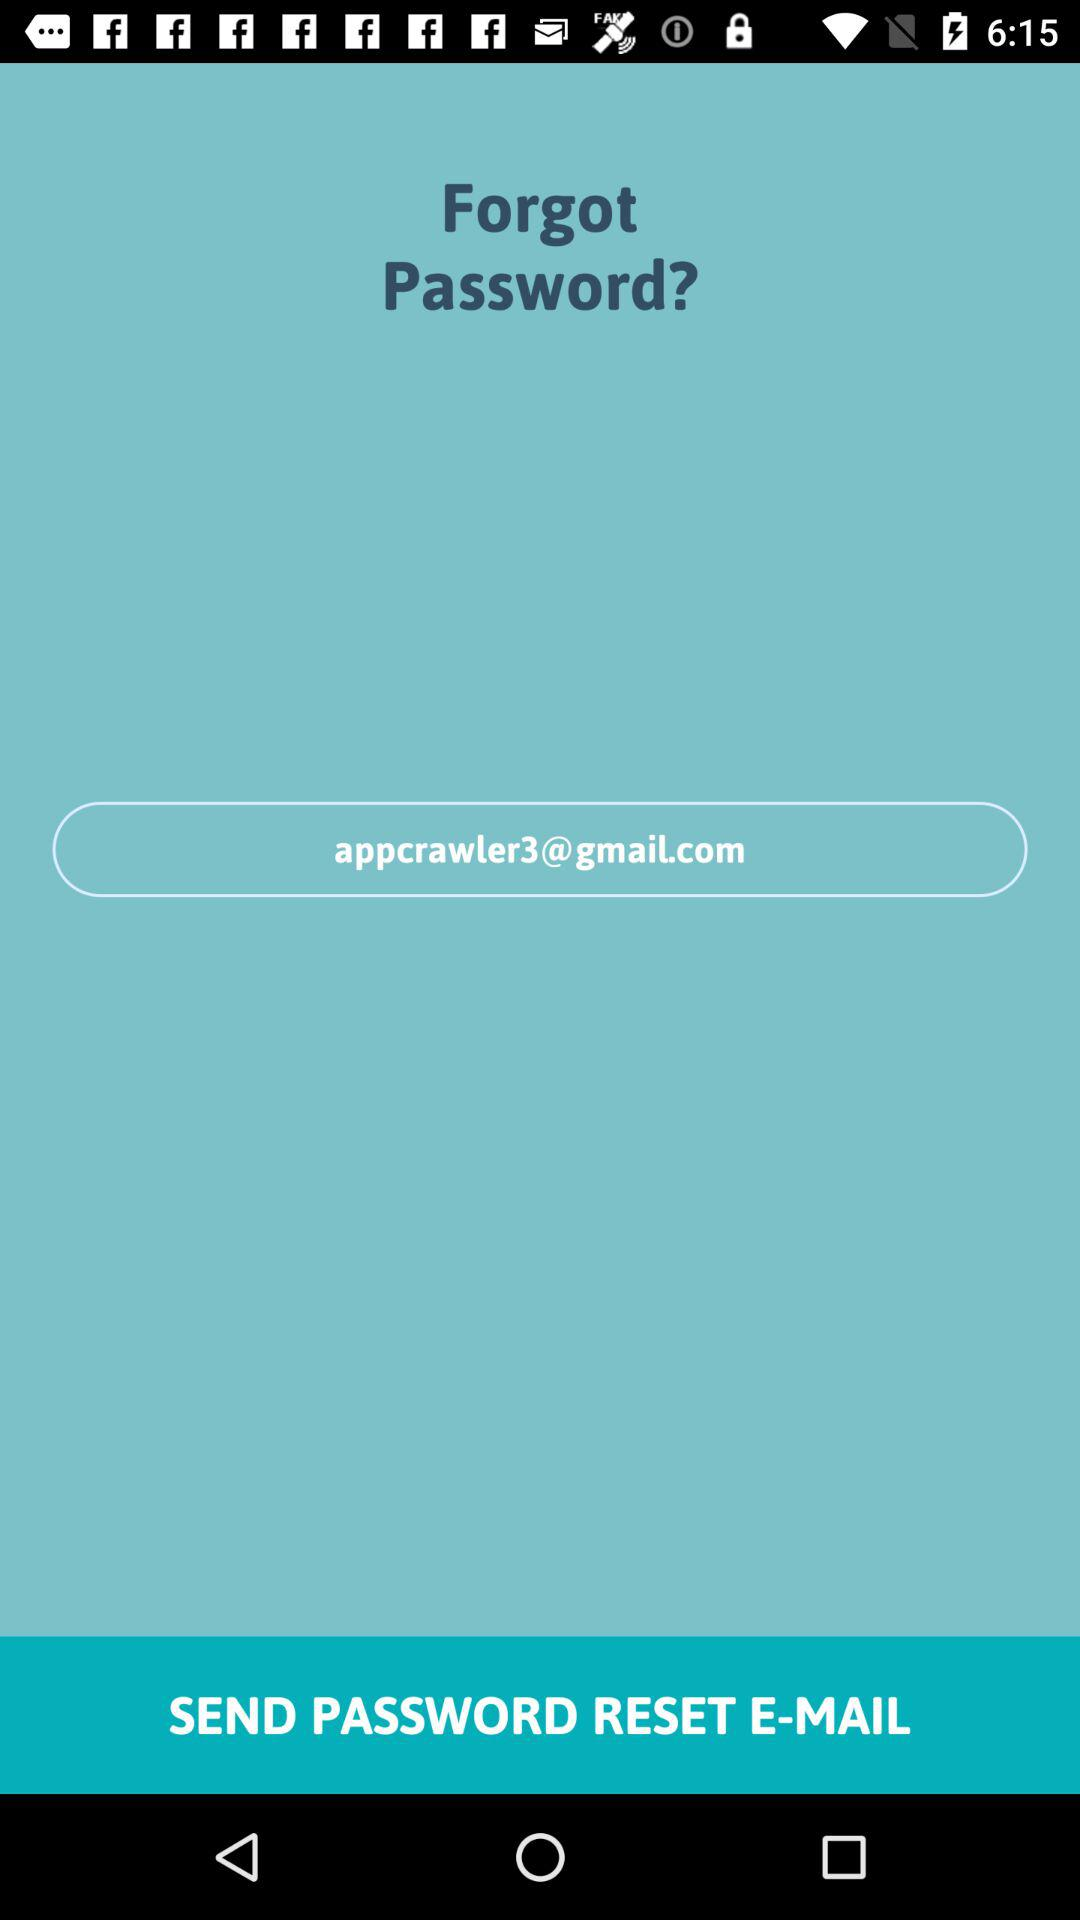What is the email address? The email address is appcrawler3@gmail.com. 